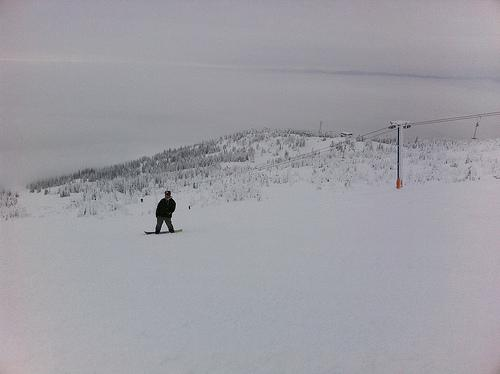Question: what is the man doing?
Choices:
A. Eating.
B. Watching television.
C. Walking to work.
D. Standing in the snow.
Answer with the letter. Answer: D Question: how many men are standing in the snow?
Choices:
A. Two.
B. One.
C. Three.
D. Four.
Answer with the letter. Answer: B Question: what color is the coat?
Choices:
A. Yellow.
B. Red.
C. Blue.
D. Black.
Answer with the letter. Answer: D Question: who is standing in the snow?
Choices:
A. A horse.
B. A group of people.
C. A small child.
D. A man.
Answer with the letter. Answer: D 